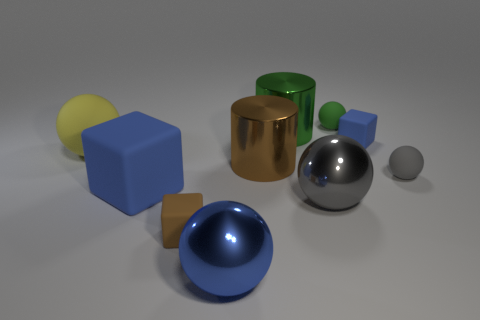Subtract all blue spheres. How many blue cubes are left? 2 Subtract all blue rubber cubes. How many cubes are left? 1 Subtract all blue blocks. How many blocks are left? 1 Subtract all cylinders. How many objects are left? 8 Subtract 1 cubes. How many cubes are left? 2 Subtract all blue cubes. Subtract all gray spheres. How many cubes are left? 1 Subtract all big red spheres. Subtract all big blue rubber objects. How many objects are left? 9 Add 9 tiny blue objects. How many tiny blue objects are left? 10 Add 8 big gray objects. How many big gray objects exist? 9 Subtract 1 brown blocks. How many objects are left? 9 